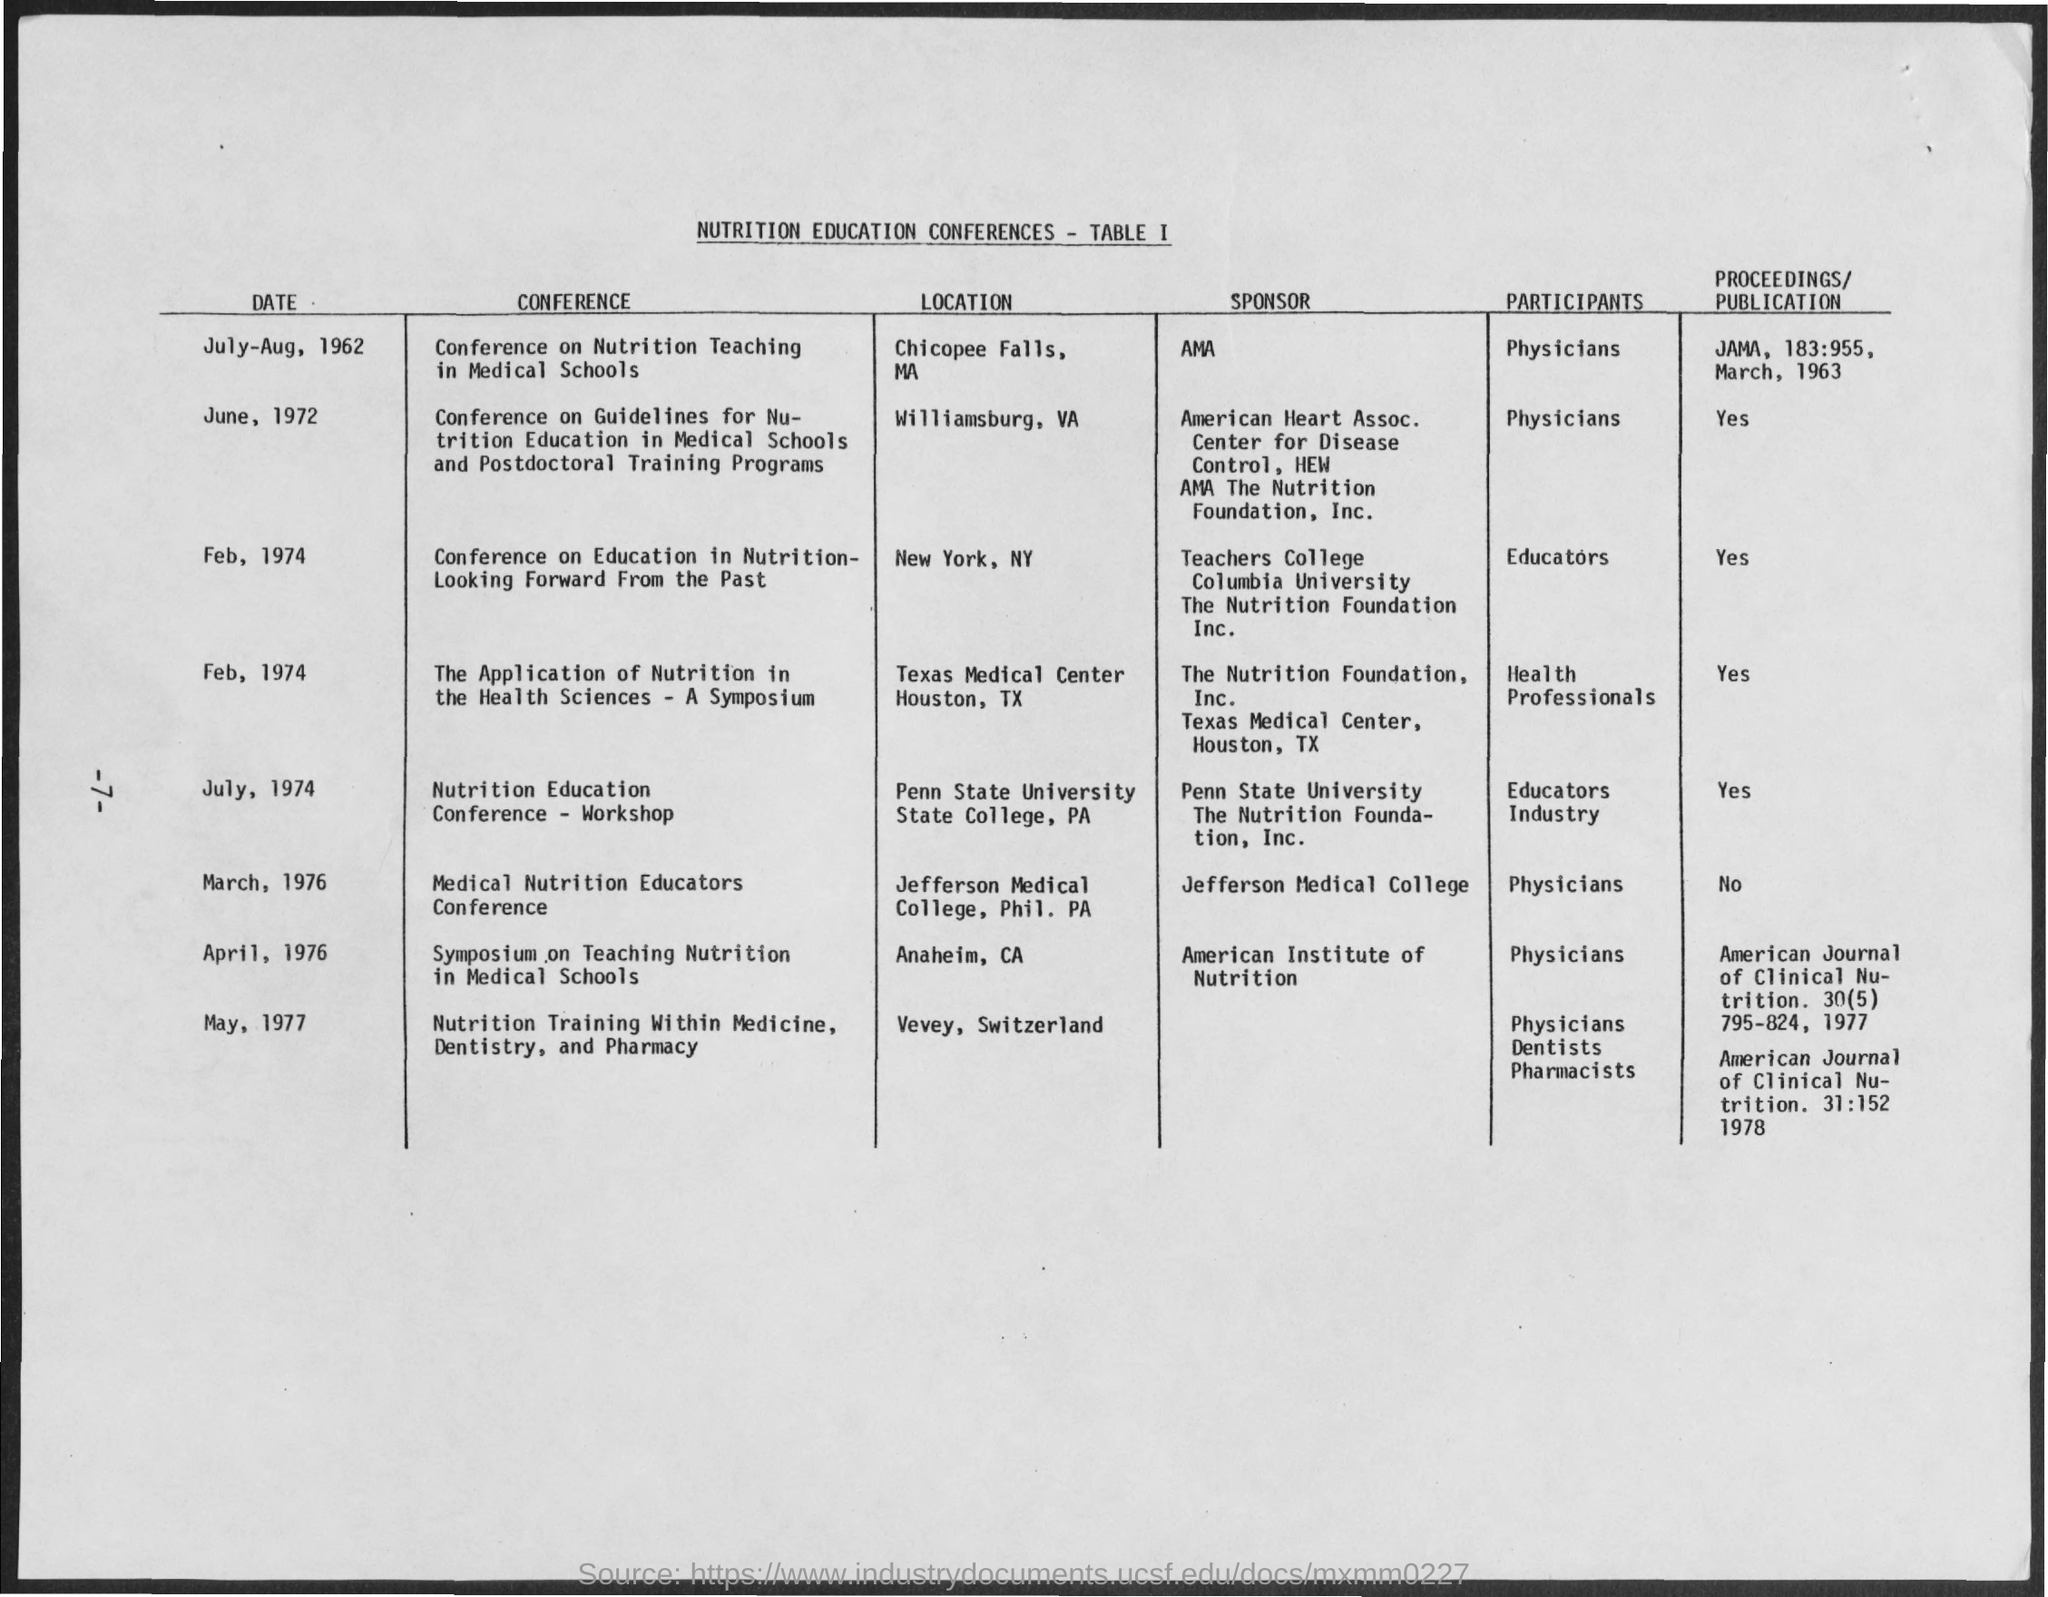What is the Date for Conference on Nutrition Teaching in Medical Schools?
Provide a succinct answer. July-Aug, 1962. What is the Location Conference on Nutrition Teaching in Medical Schools?
Ensure brevity in your answer.  Chicopee Falls, MA. Who is the Sponsor for Conference on Nutrition Teaching in Medical Schools?
Provide a short and direct response. AMA. What is the Proceedings/Publication for Conference on Nutrition Teaching in Medical Schools?
Give a very brief answer. JAMA, 183:955, March, 1963. What is the Date for Nutrtion Education Conference - Workshop?
Your response must be concise. July, 1974. What is the location for  Nutrtion Education Conference - Workshop?
Offer a terse response. Penn State University. Who are the participants for  Nutrtion Education Conference - Workshop?
Your answer should be very brief. Educators. Who are the participants Conference on Nutrition Teaching in Medical Schools?
Provide a succinct answer. Physicians. 